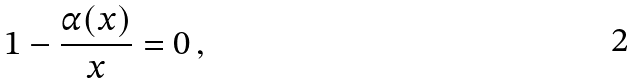<formula> <loc_0><loc_0><loc_500><loc_500>1 - \frac { \alpha ( x ) } { x } = 0 \, ,</formula> 